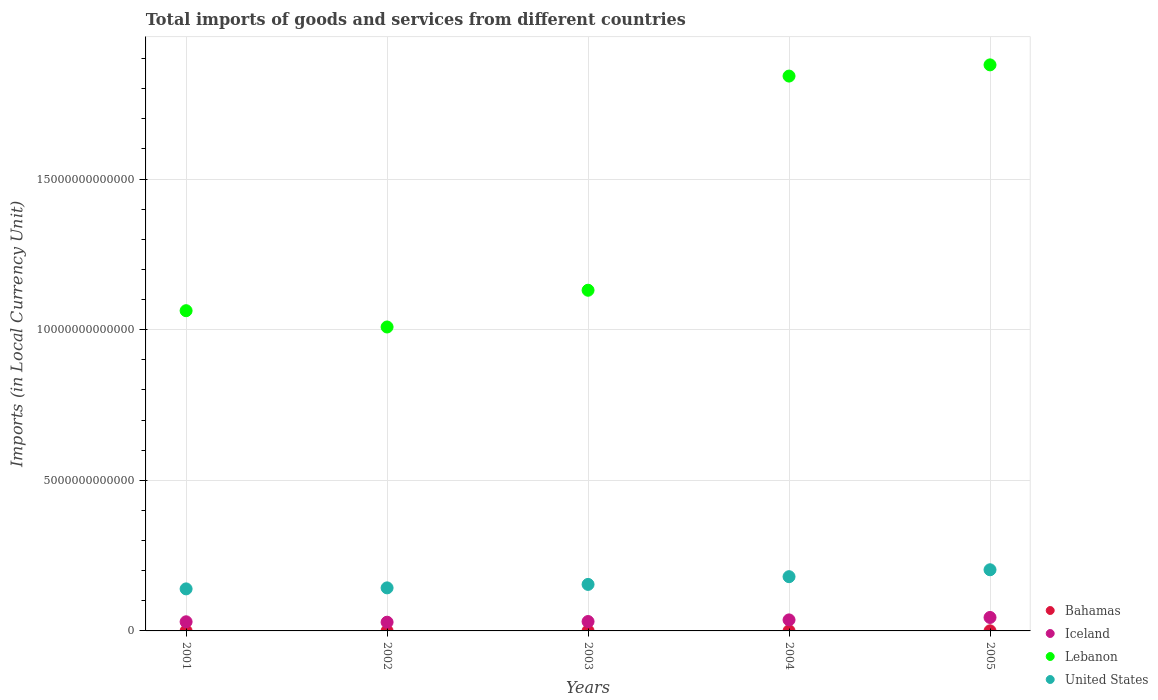What is the Amount of goods and services imports in Iceland in 2004?
Provide a succinct answer. 3.66e+11. Across all years, what is the maximum Amount of goods and services imports in Lebanon?
Your answer should be compact. 1.88e+13. Across all years, what is the minimum Amount of goods and services imports in United States?
Provide a short and direct response. 1.40e+12. In which year was the Amount of goods and services imports in Iceland minimum?
Give a very brief answer. 2002. What is the total Amount of goods and services imports in Iceland in the graph?
Offer a terse response. 1.72e+12. What is the difference between the Amount of goods and services imports in United States in 2003 and that in 2005?
Make the answer very short. -4.86e+11. What is the difference between the Amount of goods and services imports in United States in 2002 and the Amount of goods and services imports in Iceland in 2003?
Your response must be concise. 1.12e+12. What is the average Amount of goods and services imports in Lebanon per year?
Ensure brevity in your answer.  1.38e+13. In the year 2005, what is the difference between the Amount of goods and services imports in Iceland and Amount of goods and services imports in United States?
Give a very brief answer. -1.58e+12. In how many years, is the Amount of goods and services imports in United States greater than 6000000000000 LCU?
Your response must be concise. 0. What is the ratio of the Amount of goods and services imports in Lebanon in 2003 to that in 2005?
Keep it short and to the point. 0.6. Is the Amount of goods and services imports in Lebanon in 2002 less than that in 2003?
Provide a short and direct response. Yes. What is the difference between the highest and the second highest Amount of goods and services imports in Lebanon?
Give a very brief answer. 3.72e+11. What is the difference between the highest and the lowest Amount of goods and services imports in Iceland?
Ensure brevity in your answer.  1.57e+11. Is the sum of the Amount of goods and services imports in Bahamas in 2002 and 2003 greater than the maximum Amount of goods and services imports in Iceland across all years?
Offer a very short reply. No. Does the Amount of goods and services imports in Iceland monotonically increase over the years?
Make the answer very short. No. Is the Amount of goods and services imports in Iceland strictly greater than the Amount of goods and services imports in Lebanon over the years?
Your answer should be very brief. No. Is the Amount of goods and services imports in United States strictly less than the Amount of goods and services imports in Bahamas over the years?
Offer a terse response. No. What is the difference between two consecutive major ticks on the Y-axis?
Provide a short and direct response. 5.00e+12. Does the graph contain any zero values?
Your answer should be very brief. No. Does the graph contain grids?
Offer a terse response. Yes. How are the legend labels stacked?
Keep it short and to the point. Vertical. What is the title of the graph?
Offer a terse response. Total imports of goods and services from different countries. Does "Switzerland" appear as one of the legend labels in the graph?
Ensure brevity in your answer.  No. What is the label or title of the Y-axis?
Your answer should be very brief. Imports (in Local Currency Unit). What is the Imports (in Local Currency Unit) in Bahamas in 2001?
Provide a succinct answer. 2.82e+09. What is the Imports (in Local Currency Unit) in Iceland in 2001?
Ensure brevity in your answer.  3.03e+11. What is the Imports (in Local Currency Unit) of Lebanon in 2001?
Give a very brief answer. 1.06e+13. What is the Imports (in Local Currency Unit) in United States in 2001?
Provide a short and direct response. 1.40e+12. What is the Imports (in Local Currency Unit) in Bahamas in 2002?
Give a very brief answer. 2.67e+09. What is the Imports (in Local Currency Unit) in Iceland in 2002?
Your answer should be very brief. 2.90e+11. What is the Imports (in Local Currency Unit) of Lebanon in 2002?
Offer a very short reply. 1.01e+13. What is the Imports (in Local Currency Unit) in United States in 2002?
Ensure brevity in your answer.  1.43e+12. What is the Imports (in Local Currency Unit) in Bahamas in 2003?
Provide a succinct answer. 2.76e+09. What is the Imports (in Local Currency Unit) in Iceland in 2003?
Provide a succinct answer. 3.12e+11. What is the Imports (in Local Currency Unit) in Lebanon in 2003?
Provide a succinct answer. 1.13e+13. What is the Imports (in Local Currency Unit) of United States in 2003?
Provide a succinct answer. 1.54e+12. What is the Imports (in Local Currency Unit) of Bahamas in 2004?
Provide a succinct answer. 3.02e+09. What is the Imports (in Local Currency Unit) in Iceland in 2004?
Offer a very short reply. 3.66e+11. What is the Imports (in Local Currency Unit) of Lebanon in 2004?
Make the answer very short. 1.84e+13. What is the Imports (in Local Currency Unit) in United States in 2004?
Ensure brevity in your answer.  1.80e+12. What is the Imports (in Local Currency Unit) in Bahamas in 2005?
Make the answer very short. 3.70e+09. What is the Imports (in Local Currency Unit) in Iceland in 2005?
Your answer should be compact. 4.47e+11. What is the Imports (in Local Currency Unit) of Lebanon in 2005?
Your answer should be very brief. 1.88e+13. What is the Imports (in Local Currency Unit) in United States in 2005?
Give a very brief answer. 2.03e+12. Across all years, what is the maximum Imports (in Local Currency Unit) in Bahamas?
Provide a succinct answer. 3.70e+09. Across all years, what is the maximum Imports (in Local Currency Unit) of Iceland?
Your answer should be very brief. 4.47e+11. Across all years, what is the maximum Imports (in Local Currency Unit) of Lebanon?
Offer a very short reply. 1.88e+13. Across all years, what is the maximum Imports (in Local Currency Unit) of United States?
Make the answer very short. 2.03e+12. Across all years, what is the minimum Imports (in Local Currency Unit) in Bahamas?
Your answer should be compact. 2.67e+09. Across all years, what is the minimum Imports (in Local Currency Unit) in Iceland?
Your response must be concise. 2.90e+11. Across all years, what is the minimum Imports (in Local Currency Unit) in Lebanon?
Provide a short and direct response. 1.01e+13. Across all years, what is the minimum Imports (in Local Currency Unit) of United States?
Your answer should be compact. 1.40e+12. What is the total Imports (in Local Currency Unit) of Bahamas in the graph?
Provide a succinct answer. 1.50e+1. What is the total Imports (in Local Currency Unit) in Iceland in the graph?
Keep it short and to the point. 1.72e+12. What is the total Imports (in Local Currency Unit) of Lebanon in the graph?
Offer a very short reply. 6.92e+13. What is the total Imports (in Local Currency Unit) in United States in the graph?
Make the answer very short. 8.20e+12. What is the difference between the Imports (in Local Currency Unit) in Bahamas in 2001 and that in 2002?
Your answer should be compact. 1.48e+08. What is the difference between the Imports (in Local Currency Unit) in Iceland in 2001 and that in 2002?
Make the answer very short. 1.34e+1. What is the difference between the Imports (in Local Currency Unit) in Lebanon in 2001 and that in 2002?
Give a very brief answer. 5.41e+11. What is the difference between the Imports (in Local Currency Unit) of United States in 2001 and that in 2002?
Provide a succinct answer. -3.36e+1. What is the difference between the Imports (in Local Currency Unit) of Bahamas in 2001 and that in 2003?
Give a very brief answer. 6.12e+07. What is the difference between the Imports (in Local Currency Unit) of Iceland in 2001 and that in 2003?
Offer a terse response. -8.72e+09. What is the difference between the Imports (in Local Currency Unit) in Lebanon in 2001 and that in 2003?
Offer a very short reply. -6.79e+11. What is the difference between the Imports (in Local Currency Unit) of United States in 2001 and that in 2003?
Provide a short and direct response. -1.49e+11. What is the difference between the Imports (in Local Currency Unit) of Bahamas in 2001 and that in 2004?
Provide a short and direct response. -1.99e+08. What is the difference between the Imports (in Local Currency Unit) of Iceland in 2001 and that in 2004?
Offer a very short reply. -6.29e+1. What is the difference between the Imports (in Local Currency Unit) in Lebanon in 2001 and that in 2004?
Offer a terse response. -7.79e+12. What is the difference between the Imports (in Local Currency Unit) in United States in 2001 and that in 2004?
Provide a short and direct response. -4.05e+11. What is the difference between the Imports (in Local Currency Unit) of Bahamas in 2001 and that in 2005?
Offer a terse response. -8.80e+08. What is the difference between the Imports (in Local Currency Unit) of Iceland in 2001 and that in 2005?
Ensure brevity in your answer.  -1.44e+11. What is the difference between the Imports (in Local Currency Unit) in Lebanon in 2001 and that in 2005?
Give a very brief answer. -8.16e+12. What is the difference between the Imports (in Local Currency Unit) of United States in 2001 and that in 2005?
Offer a terse response. -6.35e+11. What is the difference between the Imports (in Local Currency Unit) in Bahamas in 2002 and that in 2003?
Your answer should be very brief. -8.67e+07. What is the difference between the Imports (in Local Currency Unit) in Iceland in 2002 and that in 2003?
Your answer should be compact. -2.21e+1. What is the difference between the Imports (in Local Currency Unit) of Lebanon in 2002 and that in 2003?
Provide a short and direct response. -1.22e+12. What is the difference between the Imports (in Local Currency Unit) in United States in 2002 and that in 2003?
Your response must be concise. -1.15e+11. What is the difference between the Imports (in Local Currency Unit) in Bahamas in 2002 and that in 2004?
Your answer should be very brief. -3.47e+08. What is the difference between the Imports (in Local Currency Unit) in Iceland in 2002 and that in 2004?
Ensure brevity in your answer.  -7.64e+1. What is the difference between the Imports (in Local Currency Unit) of Lebanon in 2002 and that in 2004?
Your answer should be very brief. -8.33e+12. What is the difference between the Imports (in Local Currency Unit) of United States in 2002 and that in 2004?
Keep it short and to the point. -3.72e+11. What is the difference between the Imports (in Local Currency Unit) in Bahamas in 2002 and that in 2005?
Offer a very short reply. -1.03e+09. What is the difference between the Imports (in Local Currency Unit) of Iceland in 2002 and that in 2005?
Provide a succinct answer. -1.57e+11. What is the difference between the Imports (in Local Currency Unit) in Lebanon in 2002 and that in 2005?
Give a very brief answer. -8.70e+12. What is the difference between the Imports (in Local Currency Unit) in United States in 2002 and that in 2005?
Offer a terse response. -6.01e+11. What is the difference between the Imports (in Local Currency Unit) in Bahamas in 2003 and that in 2004?
Make the answer very short. -2.60e+08. What is the difference between the Imports (in Local Currency Unit) of Iceland in 2003 and that in 2004?
Give a very brief answer. -5.42e+1. What is the difference between the Imports (in Local Currency Unit) of Lebanon in 2003 and that in 2004?
Give a very brief answer. -7.11e+12. What is the difference between the Imports (in Local Currency Unit) of United States in 2003 and that in 2004?
Your answer should be very brief. -2.57e+11. What is the difference between the Imports (in Local Currency Unit) of Bahamas in 2003 and that in 2005?
Your response must be concise. -9.41e+08. What is the difference between the Imports (in Local Currency Unit) of Iceland in 2003 and that in 2005?
Make the answer very short. -1.35e+11. What is the difference between the Imports (in Local Currency Unit) of Lebanon in 2003 and that in 2005?
Your answer should be very brief. -7.48e+12. What is the difference between the Imports (in Local Currency Unit) of United States in 2003 and that in 2005?
Offer a very short reply. -4.86e+11. What is the difference between the Imports (in Local Currency Unit) in Bahamas in 2004 and that in 2005?
Your response must be concise. -6.81e+08. What is the difference between the Imports (in Local Currency Unit) of Iceland in 2004 and that in 2005?
Provide a short and direct response. -8.06e+1. What is the difference between the Imports (in Local Currency Unit) in Lebanon in 2004 and that in 2005?
Offer a very short reply. -3.72e+11. What is the difference between the Imports (in Local Currency Unit) in United States in 2004 and that in 2005?
Give a very brief answer. -2.29e+11. What is the difference between the Imports (in Local Currency Unit) in Bahamas in 2001 and the Imports (in Local Currency Unit) in Iceland in 2002?
Offer a very short reply. -2.87e+11. What is the difference between the Imports (in Local Currency Unit) of Bahamas in 2001 and the Imports (in Local Currency Unit) of Lebanon in 2002?
Your answer should be compact. -1.01e+13. What is the difference between the Imports (in Local Currency Unit) of Bahamas in 2001 and the Imports (in Local Currency Unit) of United States in 2002?
Keep it short and to the point. -1.43e+12. What is the difference between the Imports (in Local Currency Unit) of Iceland in 2001 and the Imports (in Local Currency Unit) of Lebanon in 2002?
Ensure brevity in your answer.  -9.79e+12. What is the difference between the Imports (in Local Currency Unit) of Iceland in 2001 and the Imports (in Local Currency Unit) of United States in 2002?
Your answer should be very brief. -1.13e+12. What is the difference between the Imports (in Local Currency Unit) of Lebanon in 2001 and the Imports (in Local Currency Unit) of United States in 2002?
Your answer should be compact. 9.20e+12. What is the difference between the Imports (in Local Currency Unit) in Bahamas in 2001 and the Imports (in Local Currency Unit) in Iceland in 2003?
Your answer should be compact. -3.09e+11. What is the difference between the Imports (in Local Currency Unit) of Bahamas in 2001 and the Imports (in Local Currency Unit) of Lebanon in 2003?
Provide a short and direct response. -1.13e+13. What is the difference between the Imports (in Local Currency Unit) in Bahamas in 2001 and the Imports (in Local Currency Unit) in United States in 2003?
Offer a very short reply. -1.54e+12. What is the difference between the Imports (in Local Currency Unit) of Iceland in 2001 and the Imports (in Local Currency Unit) of Lebanon in 2003?
Your answer should be compact. -1.10e+13. What is the difference between the Imports (in Local Currency Unit) in Iceland in 2001 and the Imports (in Local Currency Unit) in United States in 2003?
Your response must be concise. -1.24e+12. What is the difference between the Imports (in Local Currency Unit) of Lebanon in 2001 and the Imports (in Local Currency Unit) of United States in 2003?
Offer a very short reply. 9.09e+12. What is the difference between the Imports (in Local Currency Unit) of Bahamas in 2001 and the Imports (in Local Currency Unit) of Iceland in 2004?
Keep it short and to the point. -3.63e+11. What is the difference between the Imports (in Local Currency Unit) in Bahamas in 2001 and the Imports (in Local Currency Unit) in Lebanon in 2004?
Keep it short and to the point. -1.84e+13. What is the difference between the Imports (in Local Currency Unit) of Bahamas in 2001 and the Imports (in Local Currency Unit) of United States in 2004?
Offer a terse response. -1.80e+12. What is the difference between the Imports (in Local Currency Unit) of Iceland in 2001 and the Imports (in Local Currency Unit) of Lebanon in 2004?
Keep it short and to the point. -1.81e+13. What is the difference between the Imports (in Local Currency Unit) in Iceland in 2001 and the Imports (in Local Currency Unit) in United States in 2004?
Make the answer very short. -1.50e+12. What is the difference between the Imports (in Local Currency Unit) in Lebanon in 2001 and the Imports (in Local Currency Unit) in United States in 2004?
Your response must be concise. 8.83e+12. What is the difference between the Imports (in Local Currency Unit) in Bahamas in 2001 and the Imports (in Local Currency Unit) in Iceland in 2005?
Keep it short and to the point. -4.44e+11. What is the difference between the Imports (in Local Currency Unit) in Bahamas in 2001 and the Imports (in Local Currency Unit) in Lebanon in 2005?
Offer a very short reply. -1.88e+13. What is the difference between the Imports (in Local Currency Unit) in Bahamas in 2001 and the Imports (in Local Currency Unit) in United States in 2005?
Offer a terse response. -2.03e+12. What is the difference between the Imports (in Local Currency Unit) of Iceland in 2001 and the Imports (in Local Currency Unit) of Lebanon in 2005?
Your answer should be compact. -1.85e+13. What is the difference between the Imports (in Local Currency Unit) in Iceland in 2001 and the Imports (in Local Currency Unit) in United States in 2005?
Offer a terse response. -1.73e+12. What is the difference between the Imports (in Local Currency Unit) of Lebanon in 2001 and the Imports (in Local Currency Unit) of United States in 2005?
Provide a short and direct response. 8.60e+12. What is the difference between the Imports (in Local Currency Unit) in Bahamas in 2002 and the Imports (in Local Currency Unit) in Iceland in 2003?
Keep it short and to the point. -3.09e+11. What is the difference between the Imports (in Local Currency Unit) of Bahamas in 2002 and the Imports (in Local Currency Unit) of Lebanon in 2003?
Provide a short and direct response. -1.13e+13. What is the difference between the Imports (in Local Currency Unit) of Bahamas in 2002 and the Imports (in Local Currency Unit) of United States in 2003?
Provide a succinct answer. -1.54e+12. What is the difference between the Imports (in Local Currency Unit) in Iceland in 2002 and the Imports (in Local Currency Unit) in Lebanon in 2003?
Provide a succinct answer. -1.10e+13. What is the difference between the Imports (in Local Currency Unit) in Iceland in 2002 and the Imports (in Local Currency Unit) in United States in 2003?
Your answer should be compact. -1.25e+12. What is the difference between the Imports (in Local Currency Unit) in Lebanon in 2002 and the Imports (in Local Currency Unit) in United States in 2003?
Provide a succinct answer. 8.55e+12. What is the difference between the Imports (in Local Currency Unit) in Bahamas in 2002 and the Imports (in Local Currency Unit) in Iceland in 2004?
Offer a terse response. -3.63e+11. What is the difference between the Imports (in Local Currency Unit) of Bahamas in 2002 and the Imports (in Local Currency Unit) of Lebanon in 2004?
Your answer should be very brief. -1.84e+13. What is the difference between the Imports (in Local Currency Unit) of Bahamas in 2002 and the Imports (in Local Currency Unit) of United States in 2004?
Provide a succinct answer. -1.80e+12. What is the difference between the Imports (in Local Currency Unit) of Iceland in 2002 and the Imports (in Local Currency Unit) of Lebanon in 2004?
Provide a succinct answer. -1.81e+13. What is the difference between the Imports (in Local Currency Unit) in Iceland in 2002 and the Imports (in Local Currency Unit) in United States in 2004?
Provide a short and direct response. -1.51e+12. What is the difference between the Imports (in Local Currency Unit) of Lebanon in 2002 and the Imports (in Local Currency Unit) of United States in 2004?
Keep it short and to the point. 8.29e+12. What is the difference between the Imports (in Local Currency Unit) in Bahamas in 2002 and the Imports (in Local Currency Unit) in Iceland in 2005?
Offer a terse response. -4.44e+11. What is the difference between the Imports (in Local Currency Unit) in Bahamas in 2002 and the Imports (in Local Currency Unit) in Lebanon in 2005?
Your answer should be compact. -1.88e+13. What is the difference between the Imports (in Local Currency Unit) in Bahamas in 2002 and the Imports (in Local Currency Unit) in United States in 2005?
Your answer should be compact. -2.03e+12. What is the difference between the Imports (in Local Currency Unit) of Iceland in 2002 and the Imports (in Local Currency Unit) of Lebanon in 2005?
Ensure brevity in your answer.  -1.85e+13. What is the difference between the Imports (in Local Currency Unit) in Iceland in 2002 and the Imports (in Local Currency Unit) in United States in 2005?
Give a very brief answer. -1.74e+12. What is the difference between the Imports (in Local Currency Unit) of Lebanon in 2002 and the Imports (in Local Currency Unit) of United States in 2005?
Your answer should be compact. 8.06e+12. What is the difference between the Imports (in Local Currency Unit) in Bahamas in 2003 and the Imports (in Local Currency Unit) in Iceland in 2004?
Offer a very short reply. -3.63e+11. What is the difference between the Imports (in Local Currency Unit) in Bahamas in 2003 and the Imports (in Local Currency Unit) in Lebanon in 2004?
Keep it short and to the point. -1.84e+13. What is the difference between the Imports (in Local Currency Unit) of Bahamas in 2003 and the Imports (in Local Currency Unit) of United States in 2004?
Your answer should be compact. -1.80e+12. What is the difference between the Imports (in Local Currency Unit) of Iceland in 2003 and the Imports (in Local Currency Unit) of Lebanon in 2004?
Your answer should be very brief. -1.81e+13. What is the difference between the Imports (in Local Currency Unit) of Iceland in 2003 and the Imports (in Local Currency Unit) of United States in 2004?
Give a very brief answer. -1.49e+12. What is the difference between the Imports (in Local Currency Unit) in Lebanon in 2003 and the Imports (in Local Currency Unit) in United States in 2004?
Offer a terse response. 9.51e+12. What is the difference between the Imports (in Local Currency Unit) in Bahamas in 2003 and the Imports (in Local Currency Unit) in Iceland in 2005?
Provide a succinct answer. -4.44e+11. What is the difference between the Imports (in Local Currency Unit) in Bahamas in 2003 and the Imports (in Local Currency Unit) in Lebanon in 2005?
Your answer should be compact. -1.88e+13. What is the difference between the Imports (in Local Currency Unit) of Bahamas in 2003 and the Imports (in Local Currency Unit) of United States in 2005?
Offer a terse response. -2.03e+12. What is the difference between the Imports (in Local Currency Unit) of Iceland in 2003 and the Imports (in Local Currency Unit) of Lebanon in 2005?
Offer a very short reply. -1.85e+13. What is the difference between the Imports (in Local Currency Unit) of Iceland in 2003 and the Imports (in Local Currency Unit) of United States in 2005?
Keep it short and to the point. -1.72e+12. What is the difference between the Imports (in Local Currency Unit) in Lebanon in 2003 and the Imports (in Local Currency Unit) in United States in 2005?
Your answer should be very brief. 9.28e+12. What is the difference between the Imports (in Local Currency Unit) of Bahamas in 2004 and the Imports (in Local Currency Unit) of Iceland in 2005?
Your response must be concise. -4.44e+11. What is the difference between the Imports (in Local Currency Unit) in Bahamas in 2004 and the Imports (in Local Currency Unit) in Lebanon in 2005?
Give a very brief answer. -1.88e+13. What is the difference between the Imports (in Local Currency Unit) of Bahamas in 2004 and the Imports (in Local Currency Unit) of United States in 2005?
Give a very brief answer. -2.03e+12. What is the difference between the Imports (in Local Currency Unit) of Iceland in 2004 and the Imports (in Local Currency Unit) of Lebanon in 2005?
Your answer should be very brief. -1.84e+13. What is the difference between the Imports (in Local Currency Unit) of Iceland in 2004 and the Imports (in Local Currency Unit) of United States in 2005?
Make the answer very short. -1.66e+12. What is the difference between the Imports (in Local Currency Unit) of Lebanon in 2004 and the Imports (in Local Currency Unit) of United States in 2005?
Provide a succinct answer. 1.64e+13. What is the average Imports (in Local Currency Unit) in Bahamas per year?
Offer a very short reply. 2.99e+09. What is the average Imports (in Local Currency Unit) in Iceland per year?
Give a very brief answer. 3.44e+11. What is the average Imports (in Local Currency Unit) in Lebanon per year?
Keep it short and to the point. 1.38e+13. What is the average Imports (in Local Currency Unit) of United States per year?
Offer a terse response. 1.64e+12. In the year 2001, what is the difference between the Imports (in Local Currency Unit) of Bahamas and Imports (in Local Currency Unit) of Iceland?
Ensure brevity in your answer.  -3.00e+11. In the year 2001, what is the difference between the Imports (in Local Currency Unit) of Bahamas and Imports (in Local Currency Unit) of Lebanon?
Ensure brevity in your answer.  -1.06e+13. In the year 2001, what is the difference between the Imports (in Local Currency Unit) in Bahamas and Imports (in Local Currency Unit) in United States?
Offer a terse response. -1.39e+12. In the year 2001, what is the difference between the Imports (in Local Currency Unit) in Iceland and Imports (in Local Currency Unit) in Lebanon?
Provide a succinct answer. -1.03e+13. In the year 2001, what is the difference between the Imports (in Local Currency Unit) of Iceland and Imports (in Local Currency Unit) of United States?
Offer a very short reply. -1.09e+12. In the year 2001, what is the difference between the Imports (in Local Currency Unit) of Lebanon and Imports (in Local Currency Unit) of United States?
Your answer should be very brief. 9.23e+12. In the year 2002, what is the difference between the Imports (in Local Currency Unit) in Bahamas and Imports (in Local Currency Unit) in Iceland?
Provide a short and direct response. -2.87e+11. In the year 2002, what is the difference between the Imports (in Local Currency Unit) in Bahamas and Imports (in Local Currency Unit) in Lebanon?
Your answer should be very brief. -1.01e+13. In the year 2002, what is the difference between the Imports (in Local Currency Unit) in Bahamas and Imports (in Local Currency Unit) in United States?
Your answer should be very brief. -1.43e+12. In the year 2002, what is the difference between the Imports (in Local Currency Unit) of Iceland and Imports (in Local Currency Unit) of Lebanon?
Give a very brief answer. -9.80e+12. In the year 2002, what is the difference between the Imports (in Local Currency Unit) in Iceland and Imports (in Local Currency Unit) in United States?
Ensure brevity in your answer.  -1.14e+12. In the year 2002, what is the difference between the Imports (in Local Currency Unit) of Lebanon and Imports (in Local Currency Unit) of United States?
Make the answer very short. 8.66e+12. In the year 2003, what is the difference between the Imports (in Local Currency Unit) of Bahamas and Imports (in Local Currency Unit) of Iceland?
Offer a very short reply. -3.09e+11. In the year 2003, what is the difference between the Imports (in Local Currency Unit) of Bahamas and Imports (in Local Currency Unit) of Lebanon?
Offer a terse response. -1.13e+13. In the year 2003, what is the difference between the Imports (in Local Currency Unit) of Bahamas and Imports (in Local Currency Unit) of United States?
Keep it short and to the point. -1.54e+12. In the year 2003, what is the difference between the Imports (in Local Currency Unit) in Iceland and Imports (in Local Currency Unit) in Lebanon?
Your response must be concise. -1.10e+13. In the year 2003, what is the difference between the Imports (in Local Currency Unit) in Iceland and Imports (in Local Currency Unit) in United States?
Offer a terse response. -1.23e+12. In the year 2003, what is the difference between the Imports (in Local Currency Unit) in Lebanon and Imports (in Local Currency Unit) in United States?
Keep it short and to the point. 9.77e+12. In the year 2004, what is the difference between the Imports (in Local Currency Unit) of Bahamas and Imports (in Local Currency Unit) of Iceland?
Your answer should be very brief. -3.63e+11. In the year 2004, what is the difference between the Imports (in Local Currency Unit) in Bahamas and Imports (in Local Currency Unit) in Lebanon?
Provide a succinct answer. -1.84e+13. In the year 2004, what is the difference between the Imports (in Local Currency Unit) in Bahamas and Imports (in Local Currency Unit) in United States?
Provide a succinct answer. -1.80e+12. In the year 2004, what is the difference between the Imports (in Local Currency Unit) in Iceland and Imports (in Local Currency Unit) in Lebanon?
Provide a succinct answer. -1.81e+13. In the year 2004, what is the difference between the Imports (in Local Currency Unit) in Iceland and Imports (in Local Currency Unit) in United States?
Make the answer very short. -1.43e+12. In the year 2004, what is the difference between the Imports (in Local Currency Unit) of Lebanon and Imports (in Local Currency Unit) of United States?
Provide a short and direct response. 1.66e+13. In the year 2005, what is the difference between the Imports (in Local Currency Unit) of Bahamas and Imports (in Local Currency Unit) of Iceland?
Ensure brevity in your answer.  -4.43e+11. In the year 2005, what is the difference between the Imports (in Local Currency Unit) in Bahamas and Imports (in Local Currency Unit) in Lebanon?
Offer a very short reply. -1.88e+13. In the year 2005, what is the difference between the Imports (in Local Currency Unit) in Bahamas and Imports (in Local Currency Unit) in United States?
Your response must be concise. -2.03e+12. In the year 2005, what is the difference between the Imports (in Local Currency Unit) of Iceland and Imports (in Local Currency Unit) of Lebanon?
Offer a very short reply. -1.83e+13. In the year 2005, what is the difference between the Imports (in Local Currency Unit) of Iceland and Imports (in Local Currency Unit) of United States?
Provide a succinct answer. -1.58e+12. In the year 2005, what is the difference between the Imports (in Local Currency Unit) of Lebanon and Imports (in Local Currency Unit) of United States?
Provide a succinct answer. 1.68e+13. What is the ratio of the Imports (in Local Currency Unit) in Bahamas in 2001 to that in 2002?
Ensure brevity in your answer.  1.06. What is the ratio of the Imports (in Local Currency Unit) of Iceland in 2001 to that in 2002?
Keep it short and to the point. 1.05. What is the ratio of the Imports (in Local Currency Unit) in Lebanon in 2001 to that in 2002?
Provide a short and direct response. 1.05. What is the ratio of the Imports (in Local Currency Unit) of United States in 2001 to that in 2002?
Offer a very short reply. 0.98. What is the ratio of the Imports (in Local Currency Unit) in Bahamas in 2001 to that in 2003?
Your answer should be compact. 1.02. What is the ratio of the Imports (in Local Currency Unit) in Iceland in 2001 to that in 2003?
Keep it short and to the point. 0.97. What is the ratio of the Imports (in Local Currency Unit) in Lebanon in 2001 to that in 2003?
Offer a very short reply. 0.94. What is the ratio of the Imports (in Local Currency Unit) of United States in 2001 to that in 2003?
Make the answer very short. 0.9. What is the ratio of the Imports (in Local Currency Unit) in Bahamas in 2001 to that in 2004?
Offer a terse response. 0.93. What is the ratio of the Imports (in Local Currency Unit) of Iceland in 2001 to that in 2004?
Offer a very short reply. 0.83. What is the ratio of the Imports (in Local Currency Unit) of Lebanon in 2001 to that in 2004?
Your answer should be compact. 0.58. What is the ratio of the Imports (in Local Currency Unit) of United States in 2001 to that in 2004?
Offer a very short reply. 0.77. What is the ratio of the Imports (in Local Currency Unit) of Bahamas in 2001 to that in 2005?
Provide a succinct answer. 0.76. What is the ratio of the Imports (in Local Currency Unit) of Iceland in 2001 to that in 2005?
Keep it short and to the point. 0.68. What is the ratio of the Imports (in Local Currency Unit) in Lebanon in 2001 to that in 2005?
Ensure brevity in your answer.  0.57. What is the ratio of the Imports (in Local Currency Unit) in United States in 2001 to that in 2005?
Give a very brief answer. 0.69. What is the ratio of the Imports (in Local Currency Unit) in Bahamas in 2002 to that in 2003?
Keep it short and to the point. 0.97. What is the ratio of the Imports (in Local Currency Unit) of Iceland in 2002 to that in 2003?
Offer a very short reply. 0.93. What is the ratio of the Imports (in Local Currency Unit) of Lebanon in 2002 to that in 2003?
Make the answer very short. 0.89. What is the ratio of the Imports (in Local Currency Unit) in United States in 2002 to that in 2003?
Offer a terse response. 0.93. What is the ratio of the Imports (in Local Currency Unit) in Bahamas in 2002 to that in 2004?
Offer a terse response. 0.89. What is the ratio of the Imports (in Local Currency Unit) of Iceland in 2002 to that in 2004?
Offer a very short reply. 0.79. What is the ratio of the Imports (in Local Currency Unit) of Lebanon in 2002 to that in 2004?
Your answer should be very brief. 0.55. What is the ratio of the Imports (in Local Currency Unit) in United States in 2002 to that in 2004?
Your answer should be very brief. 0.79. What is the ratio of the Imports (in Local Currency Unit) of Bahamas in 2002 to that in 2005?
Give a very brief answer. 0.72. What is the ratio of the Imports (in Local Currency Unit) in Iceland in 2002 to that in 2005?
Your answer should be very brief. 0.65. What is the ratio of the Imports (in Local Currency Unit) of Lebanon in 2002 to that in 2005?
Make the answer very short. 0.54. What is the ratio of the Imports (in Local Currency Unit) in United States in 2002 to that in 2005?
Give a very brief answer. 0.7. What is the ratio of the Imports (in Local Currency Unit) of Bahamas in 2003 to that in 2004?
Your answer should be very brief. 0.91. What is the ratio of the Imports (in Local Currency Unit) in Iceland in 2003 to that in 2004?
Give a very brief answer. 0.85. What is the ratio of the Imports (in Local Currency Unit) in Lebanon in 2003 to that in 2004?
Offer a terse response. 0.61. What is the ratio of the Imports (in Local Currency Unit) of United States in 2003 to that in 2004?
Offer a very short reply. 0.86. What is the ratio of the Imports (in Local Currency Unit) in Bahamas in 2003 to that in 2005?
Your response must be concise. 0.75. What is the ratio of the Imports (in Local Currency Unit) in Iceland in 2003 to that in 2005?
Offer a terse response. 0.7. What is the ratio of the Imports (in Local Currency Unit) of Lebanon in 2003 to that in 2005?
Offer a very short reply. 0.6. What is the ratio of the Imports (in Local Currency Unit) in United States in 2003 to that in 2005?
Provide a succinct answer. 0.76. What is the ratio of the Imports (in Local Currency Unit) of Bahamas in 2004 to that in 2005?
Provide a short and direct response. 0.82. What is the ratio of the Imports (in Local Currency Unit) of Iceland in 2004 to that in 2005?
Your answer should be compact. 0.82. What is the ratio of the Imports (in Local Currency Unit) in Lebanon in 2004 to that in 2005?
Give a very brief answer. 0.98. What is the ratio of the Imports (in Local Currency Unit) in United States in 2004 to that in 2005?
Keep it short and to the point. 0.89. What is the difference between the highest and the second highest Imports (in Local Currency Unit) in Bahamas?
Offer a very short reply. 6.81e+08. What is the difference between the highest and the second highest Imports (in Local Currency Unit) of Iceland?
Offer a very short reply. 8.06e+1. What is the difference between the highest and the second highest Imports (in Local Currency Unit) of Lebanon?
Your response must be concise. 3.72e+11. What is the difference between the highest and the second highest Imports (in Local Currency Unit) in United States?
Make the answer very short. 2.29e+11. What is the difference between the highest and the lowest Imports (in Local Currency Unit) in Bahamas?
Your answer should be very brief. 1.03e+09. What is the difference between the highest and the lowest Imports (in Local Currency Unit) in Iceland?
Keep it short and to the point. 1.57e+11. What is the difference between the highest and the lowest Imports (in Local Currency Unit) in Lebanon?
Provide a succinct answer. 8.70e+12. What is the difference between the highest and the lowest Imports (in Local Currency Unit) of United States?
Provide a short and direct response. 6.35e+11. 